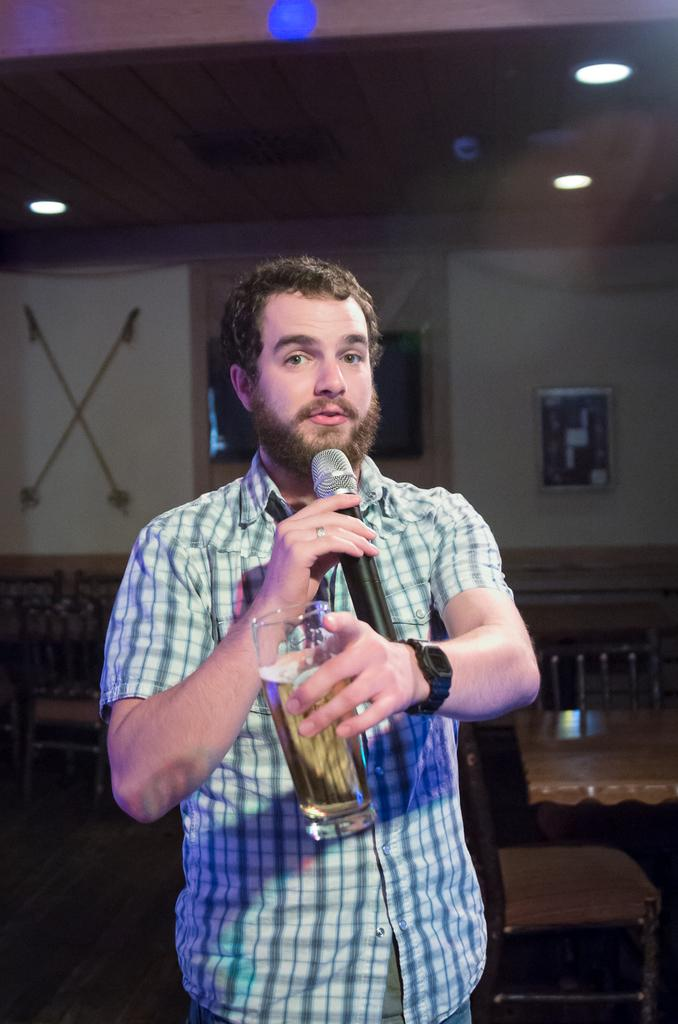What type of furniture is visible in the image? There are tables and chairs in the image. What can be seen on the ceiling in the image? There are lights on the top (presumably ceiling lights) in the image. Can you describe the person in the middle of the image? The person is holding a glass in one hand and a mic in the other hand. Is the person wearing a crown in the image? There is no crown visible on the person in the image. What type of tank is present in the image? There is no tank present in the image. 